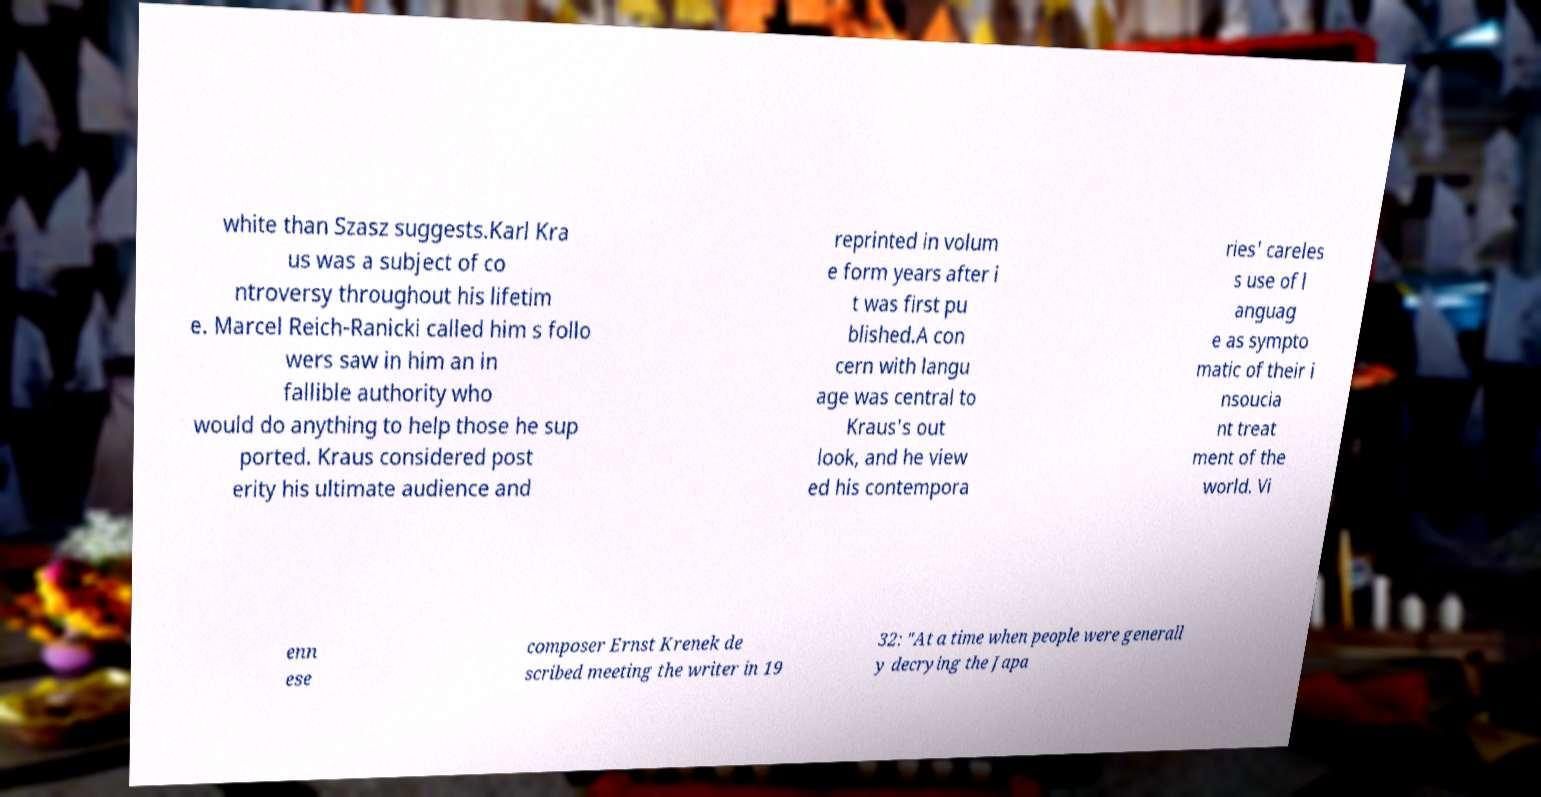Could you extract and type out the text from this image? white than Szasz suggests.Karl Kra us was a subject of co ntroversy throughout his lifetim e. Marcel Reich-Ranicki called him s follo wers saw in him an in fallible authority who would do anything to help those he sup ported. Kraus considered post erity his ultimate audience and reprinted in volum e form years after i t was first pu blished.A con cern with langu age was central to Kraus's out look, and he view ed his contempora ries' careles s use of l anguag e as sympto matic of their i nsoucia nt treat ment of the world. Vi enn ese composer Ernst Krenek de scribed meeting the writer in 19 32: "At a time when people were generall y decrying the Japa 